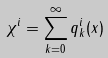Convert formula to latex. <formula><loc_0><loc_0><loc_500><loc_500>\chi ^ { i } = \sum _ { k = 0 } ^ { \infty } q ^ { i } _ { k } ( x )</formula> 